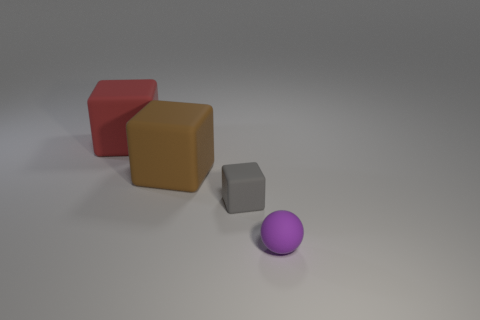Subtract all gray cubes. How many cubes are left? 2 Subtract 1 spheres. How many spheres are left? 0 Subtract all red cubes. How many cubes are left? 2 Subtract all blocks. How many objects are left? 1 Add 1 tiny gray matte objects. How many tiny gray matte objects are left? 2 Add 1 red rubber things. How many red rubber things exist? 2 Add 2 blocks. How many objects exist? 6 Subtract 0 cyan balls. How many objects are left? 4 Subtract all red balls. Subtract all brown cylinders. How many balls are left? 1 Subtract all red cylinders. How many gray cubes are left? 1 